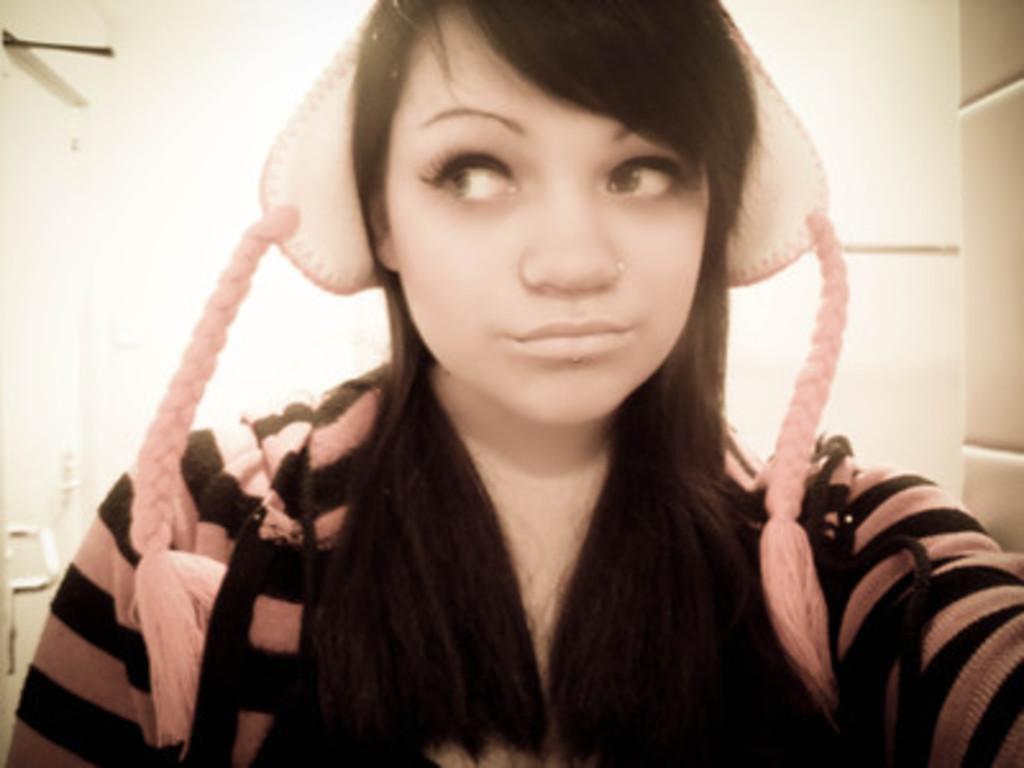Could you give a brief overview of what you see in this image? In this image there is a girl wearing a cap, in the background there is a wall. 